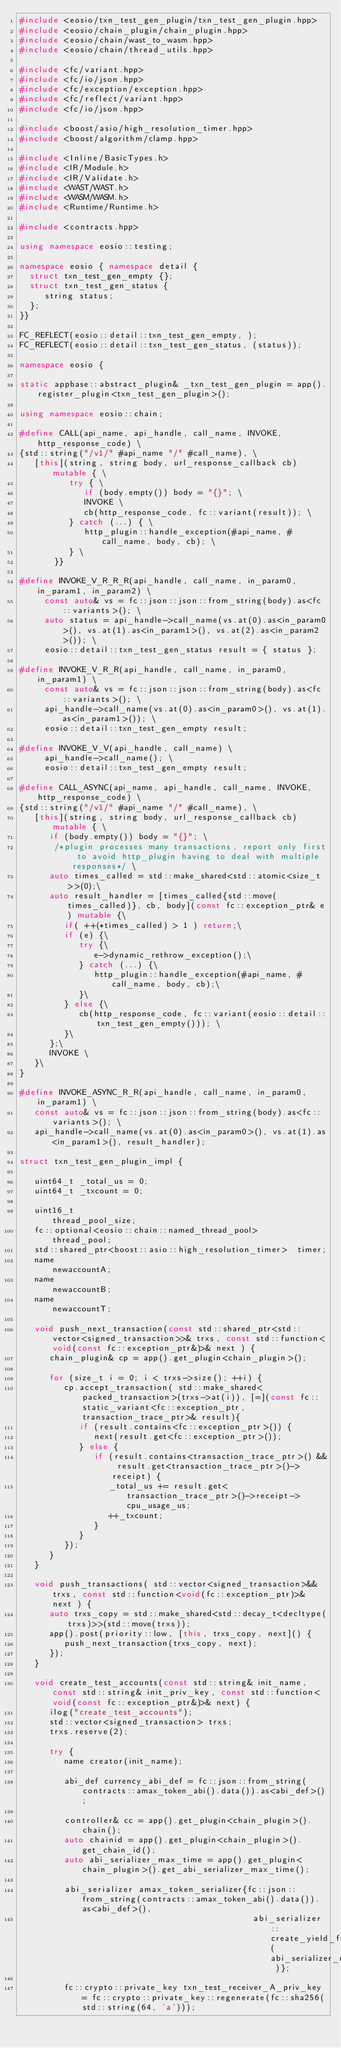<code> <loc_0><loc_0><loc_500><loc_500><_C++_>#include <eosio/txn_test_gen_plugin/txn_test_gen_plugin.hpp>
#include <eosio/chain_plugin/chain_plugin.hpp>
#include <eosio/chain/wast_to_wasm.hpp>
#include <eosio/chain/thread_utils.hpp>

#include <fc/variant.hpp>
#include <fc/io/json.hpp>
#include <fc/exception/exception.hpp>
#include <fc/reflect/variant.hpp>
#include <fc/io/json.hpp>

#include <boost/asio/high_resolution_timer.hpp>
#include <boost/algorithm/clamp.hpp>

#include <Inline/BasicTypes.h>
#include <IR/Module.h>
#include <IR/Validate.h>
#include <WAST/WAST.h>
#include <WASM/WASM.h>
#include <Runtime/Runtime.h>

#include <contracts.hpp>

using namespace eosio::testing;

namespace eosio { namespace detail {
  struct txn_test_gen_empty {};
  struct txn_test_gen_status {
     string status;
  };
}}

FC_REFLECT(eosio::detail::txn_test_gen_empty, );
FC_REFLECT(eosio::detail::txn_test_gen_status, (status));

namespace eosio {

static appbase::abstract_plugin& _txn_test_gen_plugin = app().register_plugin<txn_test_gen_plugin>();

using namespace eosio::chain;

#define CALL(api_name, api_handle, call_name, INVOKE, http_response_code) \
{std::string("/v1/" #api_name "/" #call_name), \
   [this](string, string body, url_response_callback cb) mutable { \
          try { \
             if (body.empty()) body = "{}"; \
             INVOKE \
             cb(http_response_code, fc::variant(result)); \
          } catch (...) { \
             http_plugin::handle_exception(#api_name, #call_name, body, cb); \
          } \
       }}

#define INVOKE_V_R_R_R(api_handle, call_name, in_param0, in_param1, in_param2) \
     const auto& vs = fc::json::json::from_string(body).as<fc::variants>(); \
     auto status = api_handle->call_name(vs.at(0).as<in_param0>(), vs.at(1).as<in_param1>(), vs.at(2).as<in_param2>()); \
     eosio::detail::txn_test_gen_status result = { status };

#define INVOKE_V_R_R(api_handle, call_name, in_param0, in_param1) \
     const auto& vs = fc::json::json::from_string(body).as<fc::variants>(); \
     api_handle->call_name(vs.at(0).as<in_param0>(), vs.at(1).as<in_param1>()); \
     eosio::detail::txn_test_gen_empty result;

#define INVOKE_V_V(api_handle, call_name) \
     api_handle->call_name(); \
     eosio::detail::txn_test_gen_empty result;

#define CALL_ASYNC(api_name, api_handle, call_name, INVOKE, http_response_code) \
{std::string("/v1/" #api_name "/" #call_name), \
   [this](string, string body, url_response_callback cb) mutable { \
      if (body.empty()) body = "{}"; \
       /*plugin processes many transactions, report only first to avoid http_plugin having to deal with multiple responses*/ \
      auto times_called = std::make_shared<std::atomic<size_t>>(0);\
      auto result_handler = [times_called{std::move(times_called)}, cb, body](const fc::exception_ptr& e) mutable {\
         if( ++(*times_called) > 1 ) return;\
         if (e) {\
            try {\
               e->dynamic_rethrow_exception();\
            } catch (...) {\
               http_plugin::handle_exception(#api_name, #call_name, body, cb);\
            }\
         } else {\
            cb(http_response_code, fc::variant(eosio::detail::txn_test_gen_empty())); \
         }\
      };\
      INVOKE \
   }\
}

#define INVOKE_ASYNC_R_R(api_handle, call_name, in_param0, in_param1) \
   const auto& vs = fc::json::json::from_string(body).as<fc::variants>(); \
   api_handle->call_name(vs.at(0).as<in_param0>(), vs.at(1).as<in_param1>(), result_handler);

struct txn_test_gen_plugin_impl {

   uint64_t _total_us = 0;
   uint64_t _txcount = 0;

   uint16_t                                             thread_pool_size;
   fc::optional<eosio::chain::named_thread_pool>        thread_pool;
   std::shared_ptr<boost::asio::high_resolution_timer>  timer;
   name                                                 newaccountA;
   name                                                 newaccountB;
   name                                                 newaccountT;

   void push_next_transaction(const std::shared_ptr<std::vector<signed_transaction>>& trxs, const std::function<void(const fc::exception_ptr&)>& next ) {
      chain_plugin& cp = app().get_plugin<chain_plugin>();

      for (size_t i = 0; i < trxs->size(); ++i) {
         cp.accept_transaction( std::make_shared<packed_transaction>(trxs->at(i)), [=](const fc::static_variant<fc::exception_ptr, transaction_trace_ptr>& result){
            if (result.contains<fc::exception_ptr>()) {
               next(result.get<fc::exception_ptr>());
            } else {
               if (result.contains<transaction_trace_ptr>() && result.get<transaction_trace_ptr>()->receipt) {
                  _total_us += result.get<transaction_trace_ptr>()->receipt->cpu_usage_us;
                  ++_txcount;
               }
            }
         });
      }
   }

   void push_transactions( std::vector<signed_transaction>&& trxs, const std::function<void(fc::exception_ptr)>& next ) {
      auto trxs_copy = std::make_shared<std::decay_t<decltype(trxs)>>(std::move(trxs));
      app().post(priority::low, [this, trxs_copy, next]() {
         push_next_transaction(trxs_copy, next);
      });
   }

   void create_test_accounts(const std::string& init_name, const std::string& init_priv_key, const std::function<void(const fc::exception_ptr&)>& next) {
      ilog("create_test_accounts");
      std::vector<signed_transaction> trxs;
      trxs.reserve(2);

      try {
         name creator(init_name);

         abi_def currency_abi_def = fc::json::from_string(contracts::amax_token_abi().data()).as<abi_def>();

         controller& cc = app().get_plugin<chain_plugin>().chain();
         auto chainid = app().get_plugin<chain_plugin>().get_chain_id();
         auto abi_serializer_max_time = app().get_plugin<chain_plugin>().get_abi_serializer_max_time();

         abi_serializer amax_token_serializer{fc::json::from_string(contracts::amax_token_abi().data()).as<abi_def>(),
                                               abi_serializer::create_yield_function( abi_serializer_max_time )};

         fc::crypto::private_key txn_test_receiver_A_priv_key = fc::crypto::private_key::regenerate(fc::sha256(std::string(64, 'a')));</code> 